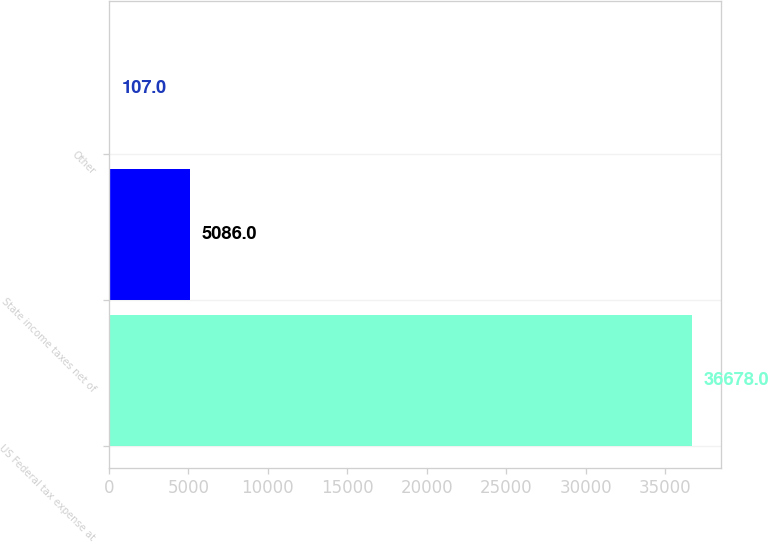<chart> <loc_0><loc_0><loc_500><loc_500><bar_chart><fcel>US Federal tax expense at<fcel>State income taxes net of<fcel>Other<nl><fcel>36678<fcel>5086<fcel>107<nl></chart> 